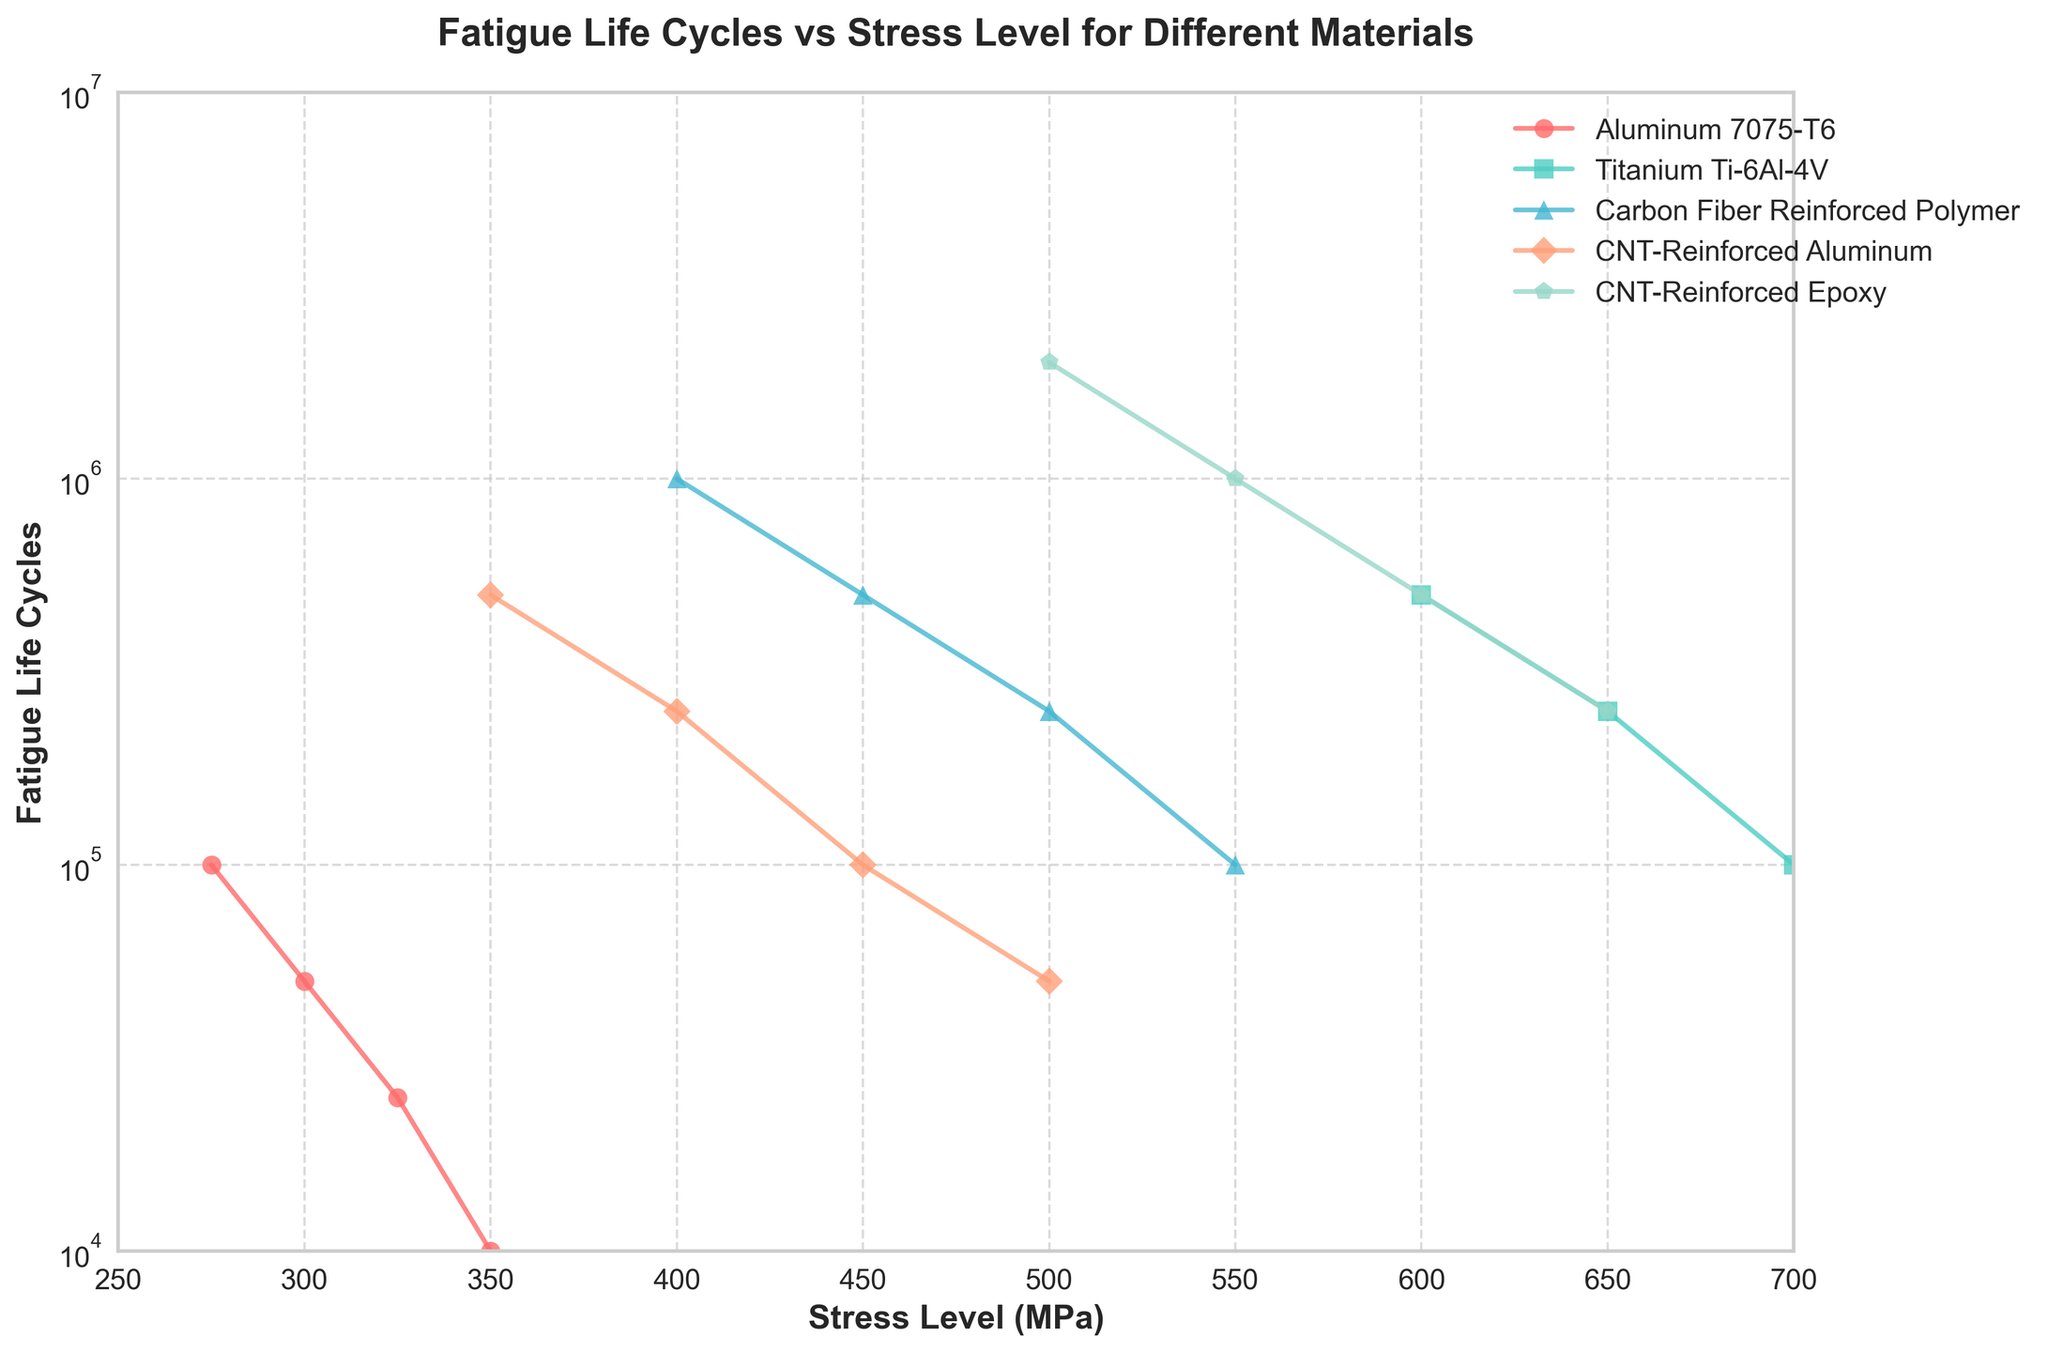What material has the longest fatigue life cycle under a stress level of 400 MPa? To determine the material with the longest fatigue life at 400 MPa, locate the data points on the x-axis at 400 MPa for each material and compare their corresponding y-axis values. Carbon Fiber Reinforced Polymer has the longest fatigue life at this stress level.
Answer: Carbon Fiber Reinforced Polymer Between Aluminum 7075-T6 and Titanium Ti-6Al-4V, which material has a greater reduction in fatigue life when the stress level increases from 300 MPa to 350 MPa? To find the reduction in fatigue life, calculate the difference in fatigue life cycles at 300 MPa and 350 MPa for each material. For Aluminum 7075-T6, the reduction is 50,000 - 10,000 = 40,000 cycles. For Titanium Ti-6Al-4V, it is 500,000 - 50,000 = 450,000 cycles. Titanium Ti-6Al-4V has a greater reduction.
Answer: Titanium Ti-6Al-4V Which material appears to have the steepest decline in fatigue life cycles as stress level increases? Assess the slopes of the lines for each material by visually inspecting the steepness of their descent. CNT-Reinforced Epoxy shows the steepest decline as stress levels increase.
Answer: CNT-Reinforced Epoxy When comparing CNT-Reinforced Aluminum and CNT-Reinforced Epoxy at a stress level of 500 MPa, which has a higher fatigue life cycle, and by how much? Identify the y-axis values for both materials at 500 MPa. CNT-Reinforced Aluminum has 50,000 cycles and CNT-Reinforced Epoxy has 2,000,000 cycles. The difference is 2,000,000 - 50,000 = 1,950,000 cycles. CNT-Reinforced Epoxy has a higher fatigue life by 1,950,000 cycles.
Answer: CNT-Reinforced Epoxy, by 1,950,000 cycles How does the fatigue life cycle of Titanium Ti-6Al-4V compare to Aluminum 7075-T6 at their respective lowest stress levels? Locate the lowest stress levels for each material and compare their corresponding fatigue life cycles. Titanium Ti-6Al-4V at 600 MPa has a fatigue life of 500,000 cycles, and Aluminum 7075-T6 at 275 MPa has 100,000 cycles. Titanium Ti-6Al-4V has a higher fatigue life cycle.
Answer: Titanium Ti-6Al-4V Which material has the least variation in fatigue life cycles across the given stress levels? Evaluate the range of fatigue life cycles for each material by comparing the maximum and minimum life cycle values. CNT-Reinforced Aluminum has values from 500,000 to 50,000, indicating the smallest range.
Answer: CNT-Reinforced Aluminum Between 450 MPa and 500 MPa, which material shows the smallest drop in fatigue life cycles? Calculate the reduction in fatigue life cycles from 450 MPa to 500 MPa for each material. CNT-Reinforced Epoxy drops from 1,000,000 to 500,000, CNT-Reinforced Aluminum drops from 100,000 to 50,000, Carbon Fiber Reinforced Polymer drops from 500,000 to 250,000, and Titanium Ti-6Al-4V drops from 100,000 to 50,000. Carbon Fiber Reinforced Polymer shows the smallest drop of 250,000 cycles.
Answer: Carbon Fiber Reinforced Polymer At the highest stress levels shown in the figure (600 MPa for CNT-Reinforced Epoxy), what is the difference in fatigue life cycles between CNT-Reinforced Epoxy and Titanium Ti-6Al-4V at a stress level of 750 MPa? Identify the fatigue life cycles at 600 MPa for CNT-Reinforced Epoxy and at 750 MPa for Titanium Ti-6Al-4V. CNT-Reinforced Epoxy has 500,000 cycles, and Titanium Ti-6Al-4V has 50,000 cycles. The difference is 500,000 - 50,000 = 450,000 cycles.
Answer: 450,000 cycles 